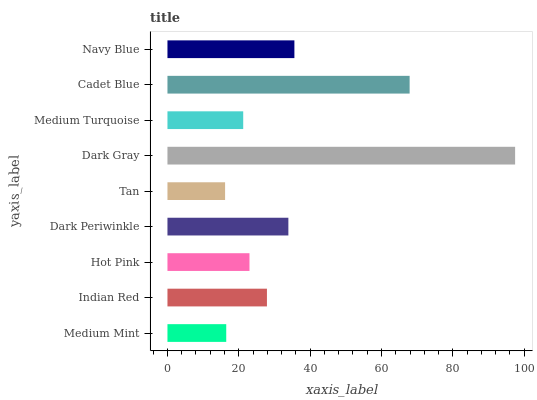Is Tan the minimum?
Answer yes or no. Yes. Is Dark Gray the maximum?
Answer yes or no. Yes. Is Indian Red the minimum?
Answer yes or no. No. Is Indian Red the maximum?
Answer yes or no. No. Is Indian Red greater than Medium Mint?
Answer yes or no. Yes. Is Medium Mint less than Indian Red?
Answer yes or no. Yes. Is Medium Mint greater than Indian Red?
Answer yes or no. No. Is Indian Red less than Medium Mint?
Answer yes or no. No. Is Indian Red the high median?
Answer yes or no. Yes. Is Indian Red the low median?
Answer yes or no. Yes. Is Medium Mint the high median?
Answer yes or no. No. Is Dark Gray the low median?
Answer yes or no. No. 